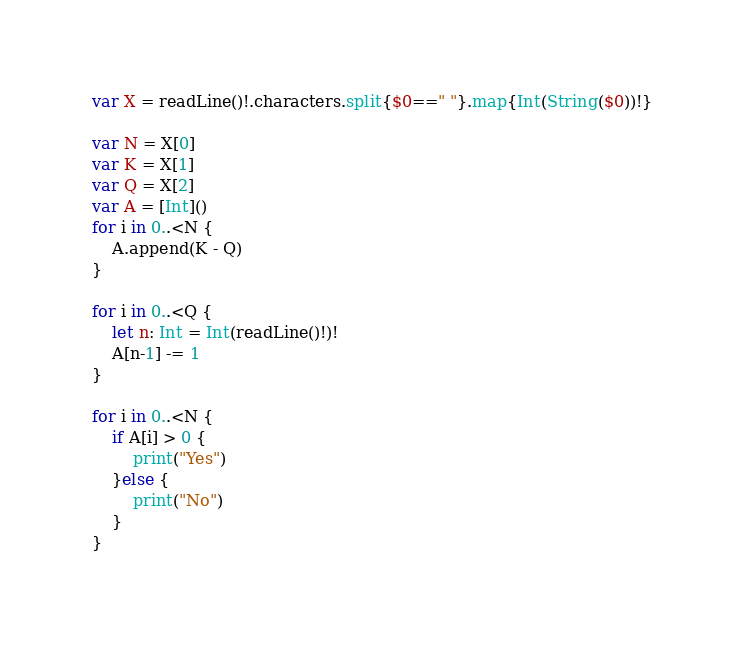Convert code to text. <code><loc_0><loc_0><loc_500><loc_500><_Swift_>var X = readLine()!.characters.split{$0==" "}.map{Int(String($0))!}

var N = X[0]
var K = X[1]
var Q = X[2]
var A = [Int]()
for i in 0..<N {
    A.append(K - Q)
}

for i in 0..<Q {
    let n: Int = Int(readLine()!)!
    A[n-1] -= 1
}

for i in 0..<N {
    if A[i] > 0 {
        print("Yes")
    }else {
        print("No")
    }
}

</code> 